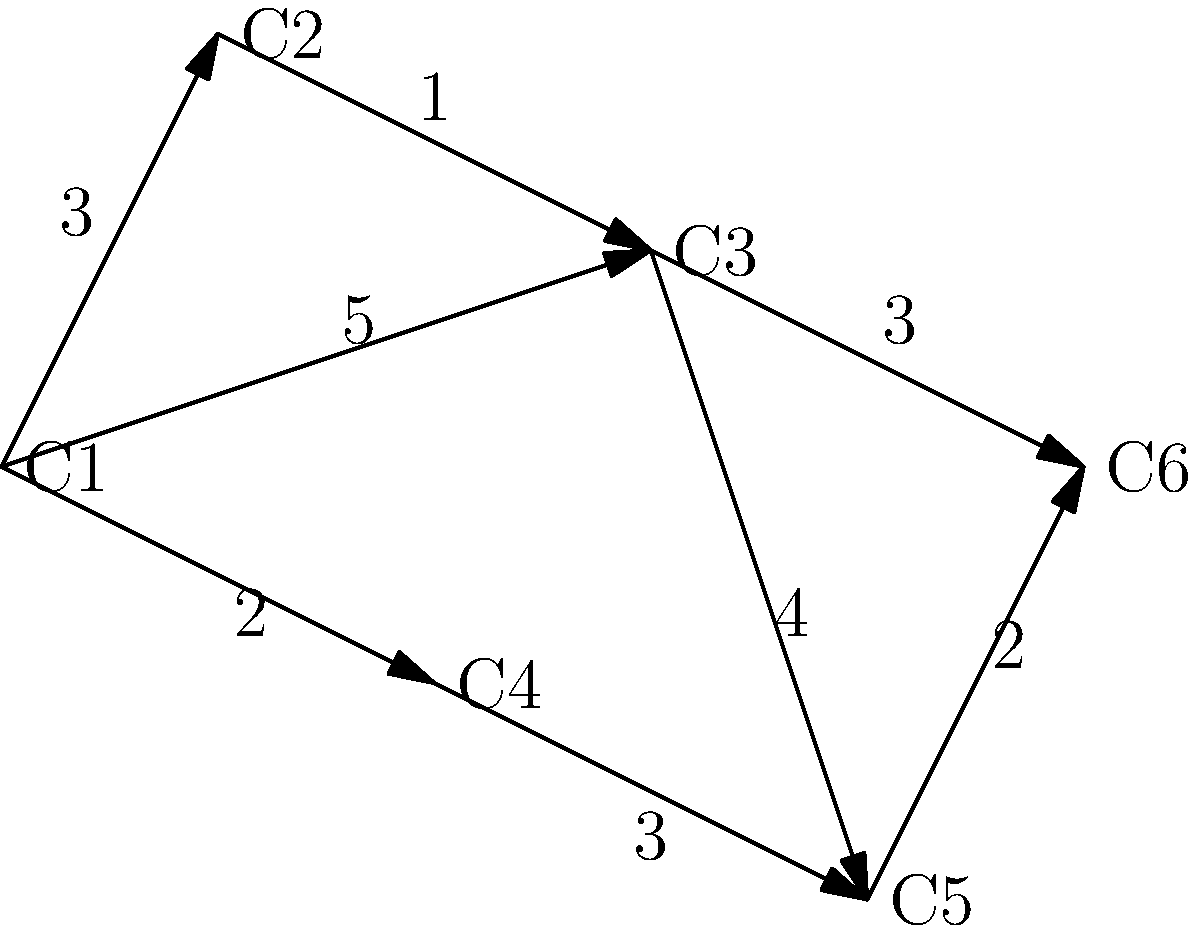On your favorite national park trail map, you notice six charming campsites connected by scenic paths. The distances between the campsites are shown in miles. If you're starting at campsite C1 and want to reach campsite C6 to hear about a fellow camper's recent bird-watching adventure, what's the shortest path you should take, and how many miles will you travel? Let's approach this step-by-step using Dijkstra's algorithm:

1) Start at C1 with distance 0. All other campsites have initial distance ∞.

2) From C1, we can reach:
   C2 (distance 3)
   C3 (distance 5)
   C4 (distance 2)

3) C4 is closest, so we mark it as visited. From C4, we can reach:
   C5 (distance 2 + 3 = 5)

4) C2 is now the closest unvisited campsite. From C2, we can reach:
   C3 (distance 3 + 1 = 4, which is better than the previous 5)

5) C3 is now closest. From C3, we can reach:
   C5 (distance 4 + 4 = 8, which is worse than the current 5)
   C6 (distance 4 + 3 = 7)

6) C5 is closest. From C5, we can reach:
   C6 (distance 5 + 2 = 7, which is the same as the current distance to C6)

7) Finally, we reach C6 with a total distance of 7 miles.

The shortest path is C1 → C4 → C5 → C6, or alternatively, C1 → C2 → C3 → C6.
Answer: C1 → C4 → C5 → C6 or C1 → C2 → C3 → C6, 7 miles 